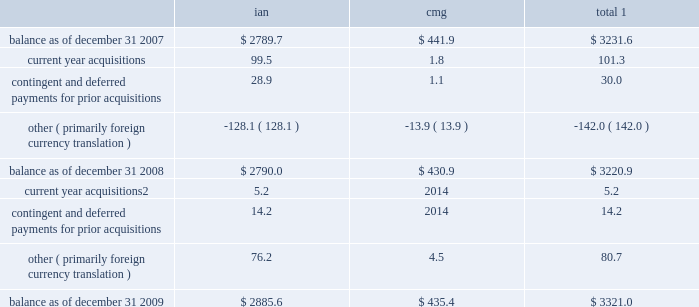Notes to consolidated financial statements 2014 ( continued ) ( amounts in millions , except per share amounts ) sales of businesses and investments 2013 primarily includes realized gains and losses relating to the sales of businesses , cumulative translation adjustment balances from the liquidation of entities and sales of marketable securities and investments in publicly traded and privately held companies in our rabbi trusts .
During 2009 , we realized a gain of $ 15.2 related to the sale of an investment in our rabbi trusts , which was partially offset by losses realized from the sale of various businesses .
Losses in 2007 primarily related to the sale of several businesses within draftfcb for a loss of $ 9.3 and charges at lowe of $ 7.8 as a result of the realization of cumulative translation adjustment balances from the liquidation of several businesses .
Vendor discounts and credit adjustments 2013 we are in the process of settling our liabilities related to vendor discounts and credits established during the restatement we presented in our 2004 annual report on form 10-k .
These adjustments reflect the reversal of certain of these liabilities as a result of settlements with clients or vendors or where the statute of limitations has lapsed .
Litigation settlement 2013 during may 2008 , the sec concluded its investigation that began in 2002 into our financial reporting practices , resulting in a settlement charge of $ 12.0 .
Investment impairments 2013 in 2007 we realized an other-than-temporary charge of $ 5.8 relating to a $ 12.5 investment in auction rate securities , representing our total investment in auction rate securities .
See note 12 for further information .
Note 5 : intangible assets goodwill goodwill is the excess purchase price remaining from an acquisition after an allocation of purchase price has been made to identifiable assets acquired and liabilities assumed based on estimated fair values .
The changes in the carrying value of goodwill for our segments , integrated agency networks ( 201cian 201d ) and constituency management group ( 201ccmg 201d ) , for the years ended december 31 , 2009 and 2008 are listed below. .
1 for all periods presented we have not recorded a goodwill impairment charge .
2 for acquisitions completed after january 1 , 2009 , amount includes contingent and deferred payments , which are recorded at fair value on the acquisition date .
See note 6 for further information .
See note 1 for further information regarding our annual impairment methodology .
Other intangible assets included in other intangible assets are assets with indefinite lives not subject to amortization and assets with definite lives subject to amortization .
Other intangible assets primarily include customer lists and trade names .
Intangible assets with definitive lives subject to amortization are amortized on a straight-line basis with estimated useful lives generally between 7 and 15 years .
Amortization expense for other intangible assets for the years ended december 31 , 2009 , 2008 and 2007 was $ 19.3 , $ 14.4 and $ 8.5 , respectively .
The following table provides a summary of other intangible assets , which are included in other assets on our consolidated balance sheets. .
What was the percentage decrease from 2007 for 2009 for the cmg balance? 
Computations: (((441.9 - 435.4) / 441.9) * 100)
Answer: 1.47092. 